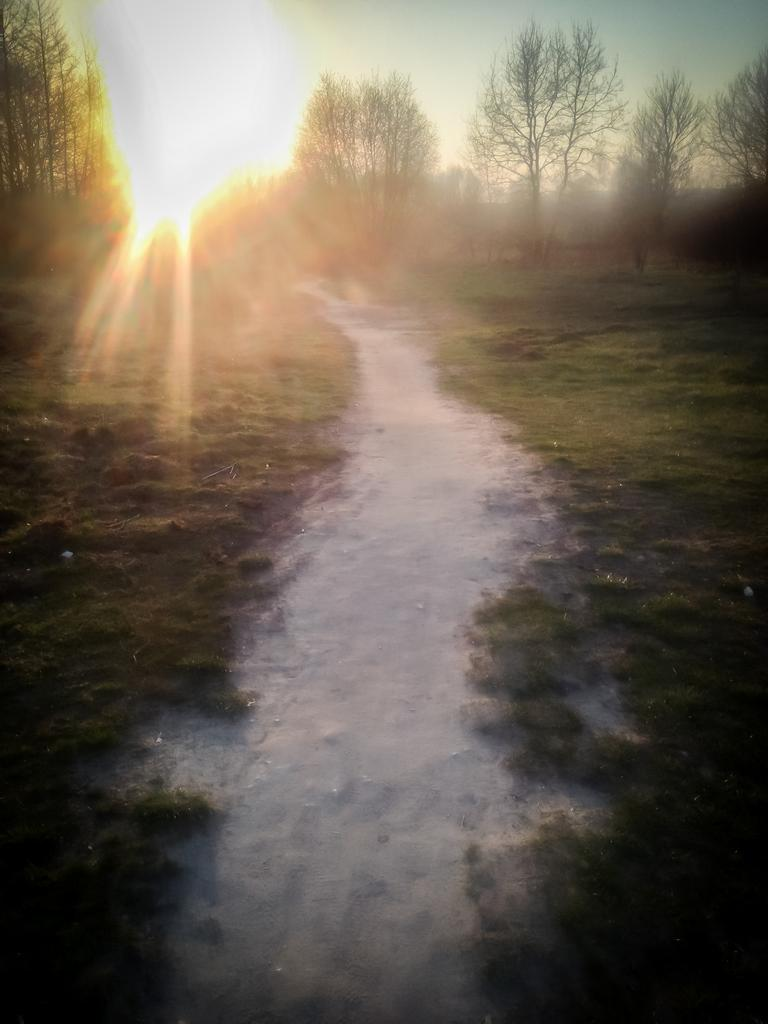What type of ground surface is visible in the image? There is grass on the ground in the image. What feature is located in the center of the image? There is a path in the center of the image. What can be seen in the background of the image? There are trees in the background of the image. What is visible at the top of the image? The sky is visible at the top of the image, and there is the sun in the sky. What type of print can be seen on the owner's shirt in the image? There is no owner or shirt present in the image; it features a grassy area with a path, trees, and the sky. 